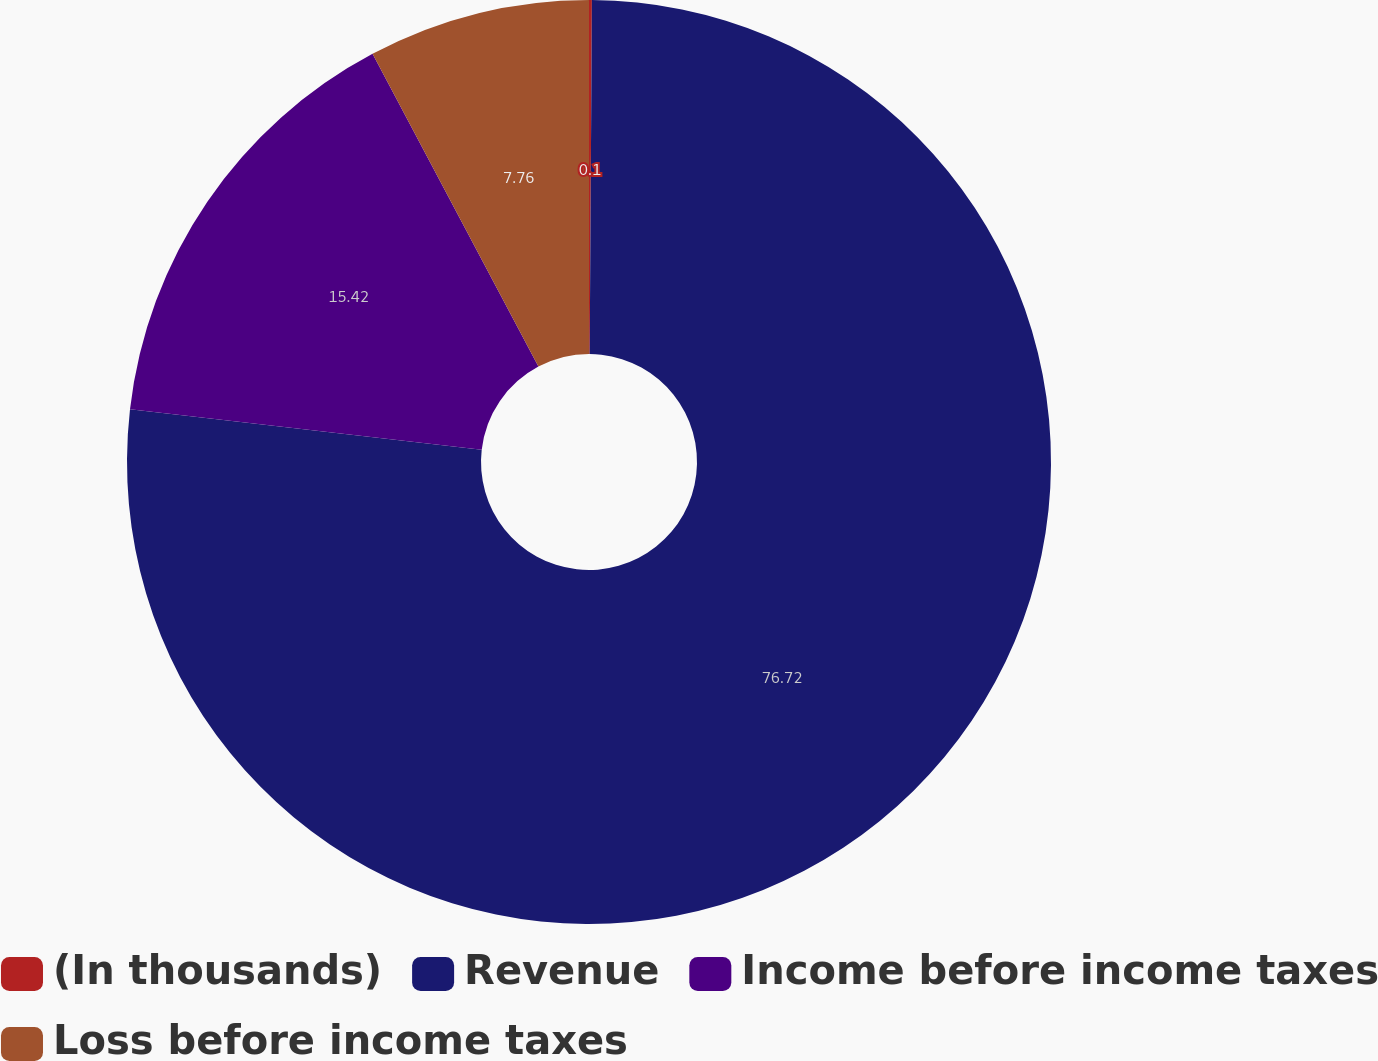<chart> <loc_0><loc_0><loc_500><loc_500><pie_chart><fcel>(In thousands)<fcel>Revenue<fcel>Income before income taxes<fcel>Loss before income taxes<nl><fcel>0.1%<fcel>76.71%<fcel>15.42%<fcel>7.76%<nl></chart> 